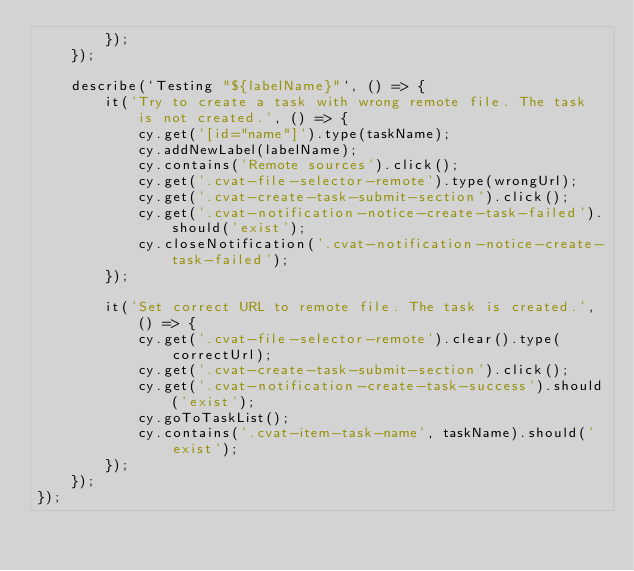<code> <loc_0><loc_0><loc_500><loc_500><_JavaScript_>        });
    });

    describe(`Testing "${labelName}"`, () => {
        it('Try to create a task with wrong remote file. The task is not created.', () => {
            cy.get('[id="name"]').type(taskName);
            cy.addNewLabel(labelName);
            cy.contains('Remote sources').click();
            cy.get('.cvat-file-selector-remote').type(wrongUrl);
            cy.get('.cvat-create-task-submit-section').click();
            cy.get('.cvat-notification-notice-create-task-failed').should('exist');
            cy.closeNotification('.cvat-notification-notice-create-task-failed');
        });

        it('Set correct URL to remote file. The task is created.', () => {
            cy.get('.cvat-file-selector-remote').clear().type(correctUrl);
            cy.get('.cvat-create-task-submit-section').click();
            cy.get('.cvat-notification-create-task-success').should('exist');
            cy.goToTaskList();
            cy.contains('.cvat-item-task-name', taskName).should('exist');
        });
    });
});
</code> 